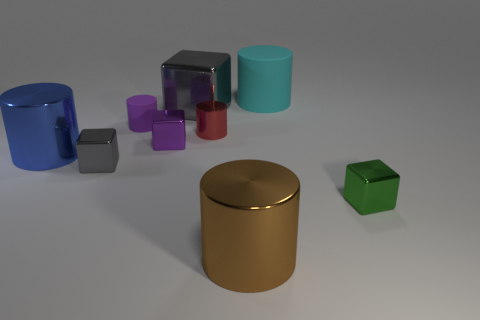Subtract 3 cylinders. How many cylinders are left? 2 Subtract all blue cylinders. How many cylinders are left? 4 Subtract all matte cylinders. How many cylinders are left? 3 Subtract all cyan cubes. Subtract all cyan spheres. How many cubes are left? 4 Add 1 tiny brown metal things. How many objects exist? 10 Subtract all cubes. How many objects are left? 5 Add 3 large cyan cylinders. How many large cyan cylinders exist? 4 Subtract 1 cyan cylinders. How many objects are left? 8 Subtract all small green metallic cubes. Subtract all brown shiny things. How many objects are left? 7 Add 8 tiny green metal blocks. How many tiny green metal blocks are left? 9 